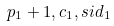<formula> <loc_0><loc_0><loc_500><loc_500>p _ { 1 } + 1 , c _ { 1 } , s i d _ { 1 }</formula> 